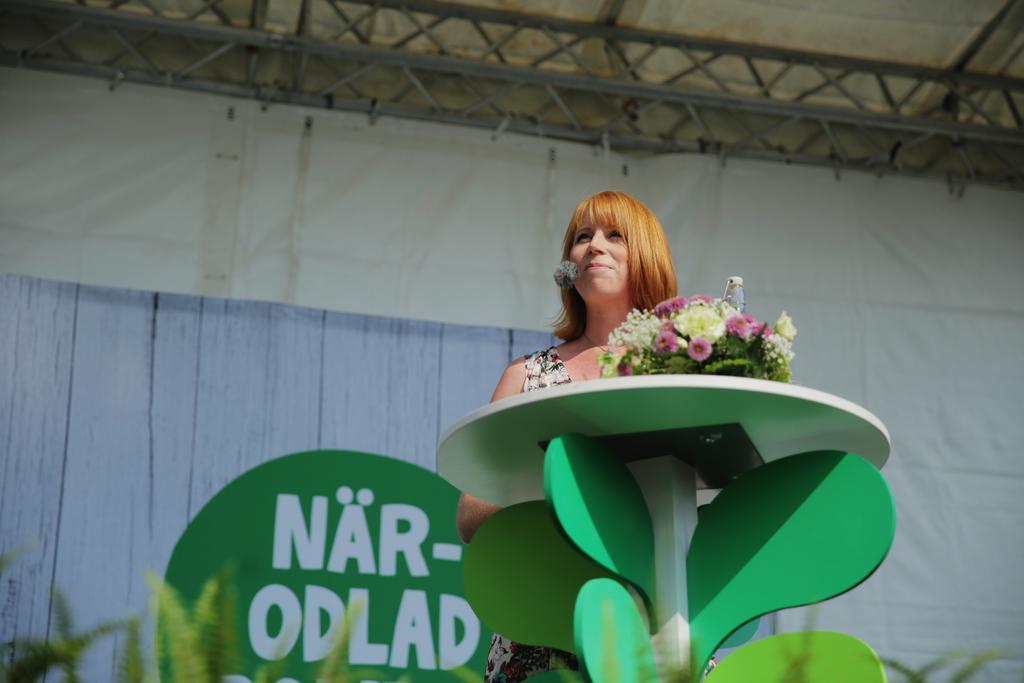How would you summarize this image in a sentence or two? In this picture we can see a women standing near to the table and smiling. On the table we can see flower bouquet. On the background we can see a banner. In Front of the picture we can see plants. 